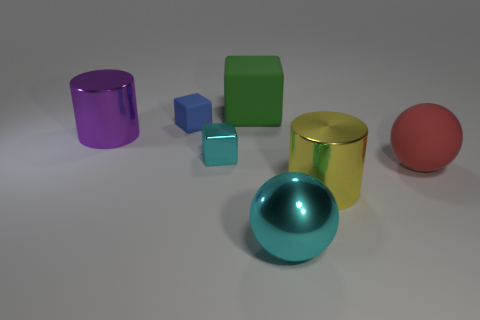What number of other things are there of the same size as the metallic ball?
Your answer should be very brief. 4. What color is the metallic cylinder that is on the right side of the purple metallic thing?
Give a very brief answer. Yellow. Is the material of the block that is behind the small rubber cube the same as the large red object?
Provide a succinct answer. Yes. How many big metallic objects are behind the small cyan shiny object and on the right side of the big purple cylinder?
Provide a succinct answer. 0. The large shiny cylinder left of the large cylinder that is to the right of the purple metallic cylinder that is behind the tiny cyan metallic object is what color?
Offer a terse response. Purple. How many other objects are there of the same shape as the tiny cyan metallic object?
Make the answer very short. 2. Is there a big cyan object behind the big cylinder behind the red matte sphere?
Ensure brevity in your answer.  No. What number of matte things are either spheres or large red objects?
Your answer should be very brief. 1. There is a big object that is both in front of the red sphere and behind the cyan sphere; what material is it made of?
Your answer should be very brief. Metal. There is a big matte thing behind the large shiny cylinder on the left side of the big cyan metallic thing; is there a big green matte cube behind it?
Give a very brief answer. No. 